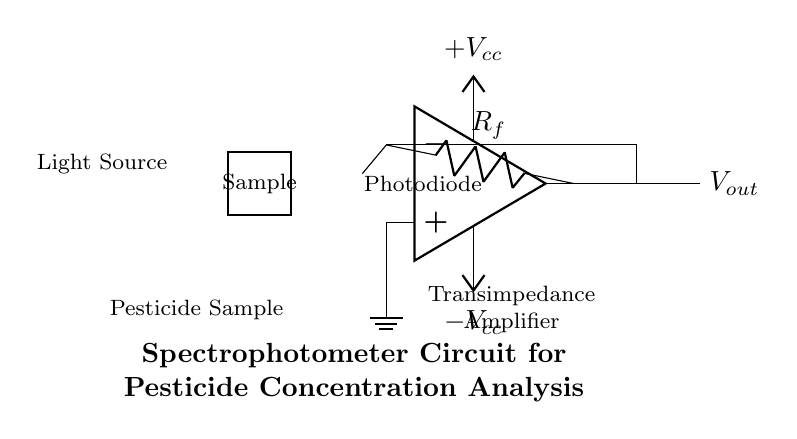what is the type of source used in this circuit? The circuit diagram indicates the use of a light source as the input, which is typically a lamp or LED for spectrophotometry.
Answer: Light source what is the role of the photodiode in this circuit? The photodiode converts light intensity into an electrical current, which is essential for measuring the light absorbed by the pesticide sample.
Answer: Light to current conversion what is the value of the output voltage indicated in the diagram? The output voltage is represented as V out in the circuit, which will depend on the current generated by the photodiode and the configuration of the transimpedance amplifier.
Answer: V out how does the feedback resistor influence the circuit's operation? The feedback resistor sets the gain of the transimpedance amplifier, impacting how much output voltage is produced for a given input current from the photodiode, which is critical for accurate concentration measurements.
Answer: Gain adjustment what does the rectangular shape in the circuit represent? The rectangle in the diagram represents the sample cuvette, which holds the pesticide solution being analyzed, allowing the light to pass through and be measured.
Answer: Sample cuvette what is the function of the transimpedance amplifier in this circuit? The transimpedance amplifier converts the small current generated by the photodiode into a larger output voltage, making it easier to read and analyze the signal related to the pesticide concentration.
Answer: Current to voltage conversion what happens if the voltage supply is disrupted in this circuit? If the voltage supply is disrupted, the function of the light source and the transimpedance amplifier will be compromised, leading to incorrect or no readings of pesticide concentration due to lack of power for operation.
Answer: No readings 